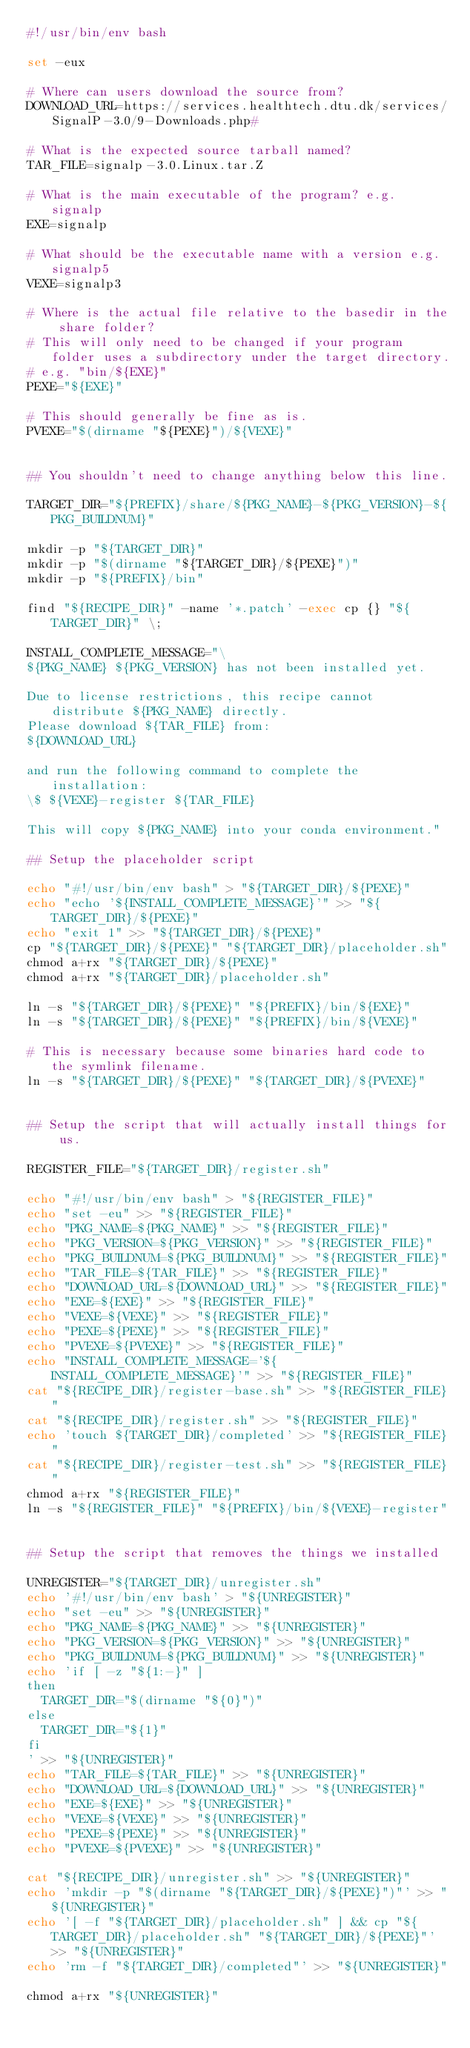Convert code to text. <code><loc_0><loc_0><loc_500><loc_500><_Bash_>#!/usr/bin/env bash

set -eux

# Where can users download the source from?
DOWNLOAD_URL=https://services.healthtech.dtu.dk/services/SignalP-3.0/9-Downloads.php#

# What is the expected source tarball named?
TAR_FILE=signalp-3.0.Linux.tar.Z

# What is the main executable of the program? e.g. signalp
EXE=signalp

# What should be the executable name with a version e.g. signalp5
VEXE=signalp3

# Where is the actual file relative to the basedir in the share folder?
# This will only need to be changed if your program folder uses a subdirectory under the target directory.
# e.g. "bin/${EXE}"
PEXE="${EXE}"

# This should generally be fine as is.
PVEXE="$(dirname "${PEXE}")/${VEXE}"


## You shouldn't need to change anything below this line.

TARGET_DIR="${PREFIX}/share/${PKG_NAME}-${PKG_VERSION}-${PKG_BUILDNUM}"

mkdir -p "${TARGET_DIR}"
mkdir -p "$(dirname "${TARGET_DIR}/${PEXE}")"
mkdir -p "${PREFIX}/bin"

find "${RECIPE_DIR}" -name '*.patch' -exec cp {} "${TARGET_DIR}" \;

INSTALL_COMPLETE_MESSAGE="\
${PKG_NAME} ${PKG_VERSION} has not been installed yet.

Due to license restrictions, this recipe cannot distribute ${PKG_NAME} directly.
Please download ${TAR_FILE} from:
${DOWNLOAD_URL}

and run the following command to complete the installation:
\$ ${VEXE}-register ${TAR_FILE}

This will copy ${PKG_NAME} into your conda environment."

## Setup the placeholder script

echo "#!/usr/bin/env bash" > "${TARGET_DIR}/${PEXE}"
echo "echo '${INSTALL_COMPLETE_MESSAGE}'" >> "${TARGET_DIR}/${PEXE}"
echo "exit 1" >> "${TARGET_DIR}/${PEXE}"
cp "${TARGET_DIR}/${PEXE}" "${TARGET_DIR}/placeholder.sh"
chmod a+rx "${TARGET_DIR}/${PEXE}"
chmod a+rx "${TARGET_DIR}/placeholder.sh"

ln -s "${TARGET_DIR}/${PEXE}" "${PREFIX}/bin/${EXE}"
ln -s "${TARGET_DIR}/${PEXE}" "${PREFIX}/bin/${VEXE}"

# This is necessary because some binaries hard code to the symlink filename.
ln -s "${TARGET_DIR}/${PEXE}" "${TARGET_DIR}/${PVEXE}"


## Setup the script that will actually install things for us.

REGISTER_FILE="${TARGET_DIR}/register.sh"

echo "#!/usr/bin/env bash" > "${REGISTER_FILE}"
echo "set -eu" >> "${REGISTER_FILE}"
echo "PKG_NAME=${PKG_NAME}" >> "${REGISTER_FILE}"
echo "PKG_VERSION=${PKG_VERSION}" >> "${REGISTER_FILE}"
echo "PKG_BUILDNUM=${PKG_BUILDNUM}" >> "${REGISTER_FILE}"
echo "TAR_FILE=${TAR_FILE}" >> "${REGISTER_FILE}"
echo "DOWNLOAD_URL=${DOWNLOAD_URL}" >> "${REGISTER_FILE}"
echo "EXE=${EXE}" >> "${REGISTER_FILE}"
echo "VEXE=${VEXE}" >> "${REGISTER_FILE}"
echo "PEXE=${PEXE}" >> "${REGISTER_FILE}"
echo "PVEXE=${PVEXE}" >> "${REGISTER_FILE}"
echo "INSTALL_COMPLETE_MESSAGE='${INSTALL_COMPLETE_MESSAGE}'" >> "${REGISTER_FILE}"
cat "${RECIPE_DIR}/register-base.sh" >> "${REGISTER_FILE}"
cat "${RECIPE_DIR}/register.sh" >> "${REGISTER_FILE}"
echo 'touch ${TARGET_DIR}/completed' >> "${REGISTER_FILE}"
cat "${RECIPE_DIR}/register-test.sh" >> "${REGISTER_FILE}"
chmod a+rx "${REGISTER_FILE}"
ln -s "${REGISTER_FILE}" "${PREFIX}/bin/${VEXE}-register"


## Setup the script that removes the things we installed

UNREGISTER="${TARGET_DIR}/unregister.sh"
echo '#!/usr/bin/env bash' > "${UNREGISTER}"
echo "set -eu" >> "${UNREGISTER}"
echo "PKG_NAME=${PKG_NAME}" >> "${UNREGISTER}"
echo "PKG_VERSION=${PKG_VERSION}" >> "${UNREGISTER}"
echo "PKG_BUILDNUM=${PKG_BUILDNUM}" >> "${UNREGISTER}"
echo 'if [ -z "${1:-}" ]
then
  TARGET_DIR="$(dirname "${0}")"
else
  TARGET_DIR="${1}"
fi
' >> "${UNREGISTER}"
echo "TAR_FILE=${TAR_FILE}" >> "${UNREGISTER}"
echo "DOWNLOAD_URL=${DOWNLOAD_URL}" >> "${UNREGISTER}"
echo "EXE=${EXE}" >> "${UNREGISTER}"
echo "VEXE=${VEXE}" >> "${UNREGISTER}"
echo "PEXE=${PEXE}" >> "${UNREGISTER}"
echo "PVEXE=${PVEXE}" >> "${UNREGISTER}"

cat "${RECIPE_DIR}/unregister.sh" >> "${UNREGISTER}"
echo 'mkdir -p "$(dirname "${TARGET_DIR}/${PEXE}")"' >> "${UNREGISTER}"
echo '[ -f "${TARGET_DIR}/placeholder.sh" ] && cp "${TARGET_DIR}/placeholder.sh" "${TARGET_DIR}/${PEXE}"' >> "${UNREGISTER}"
echo 'rm -f "${TARGET_DIR}/completed"' >> "${UNREGISTER}"

chmod a+rx "${UNREGISTER}"
</code> 